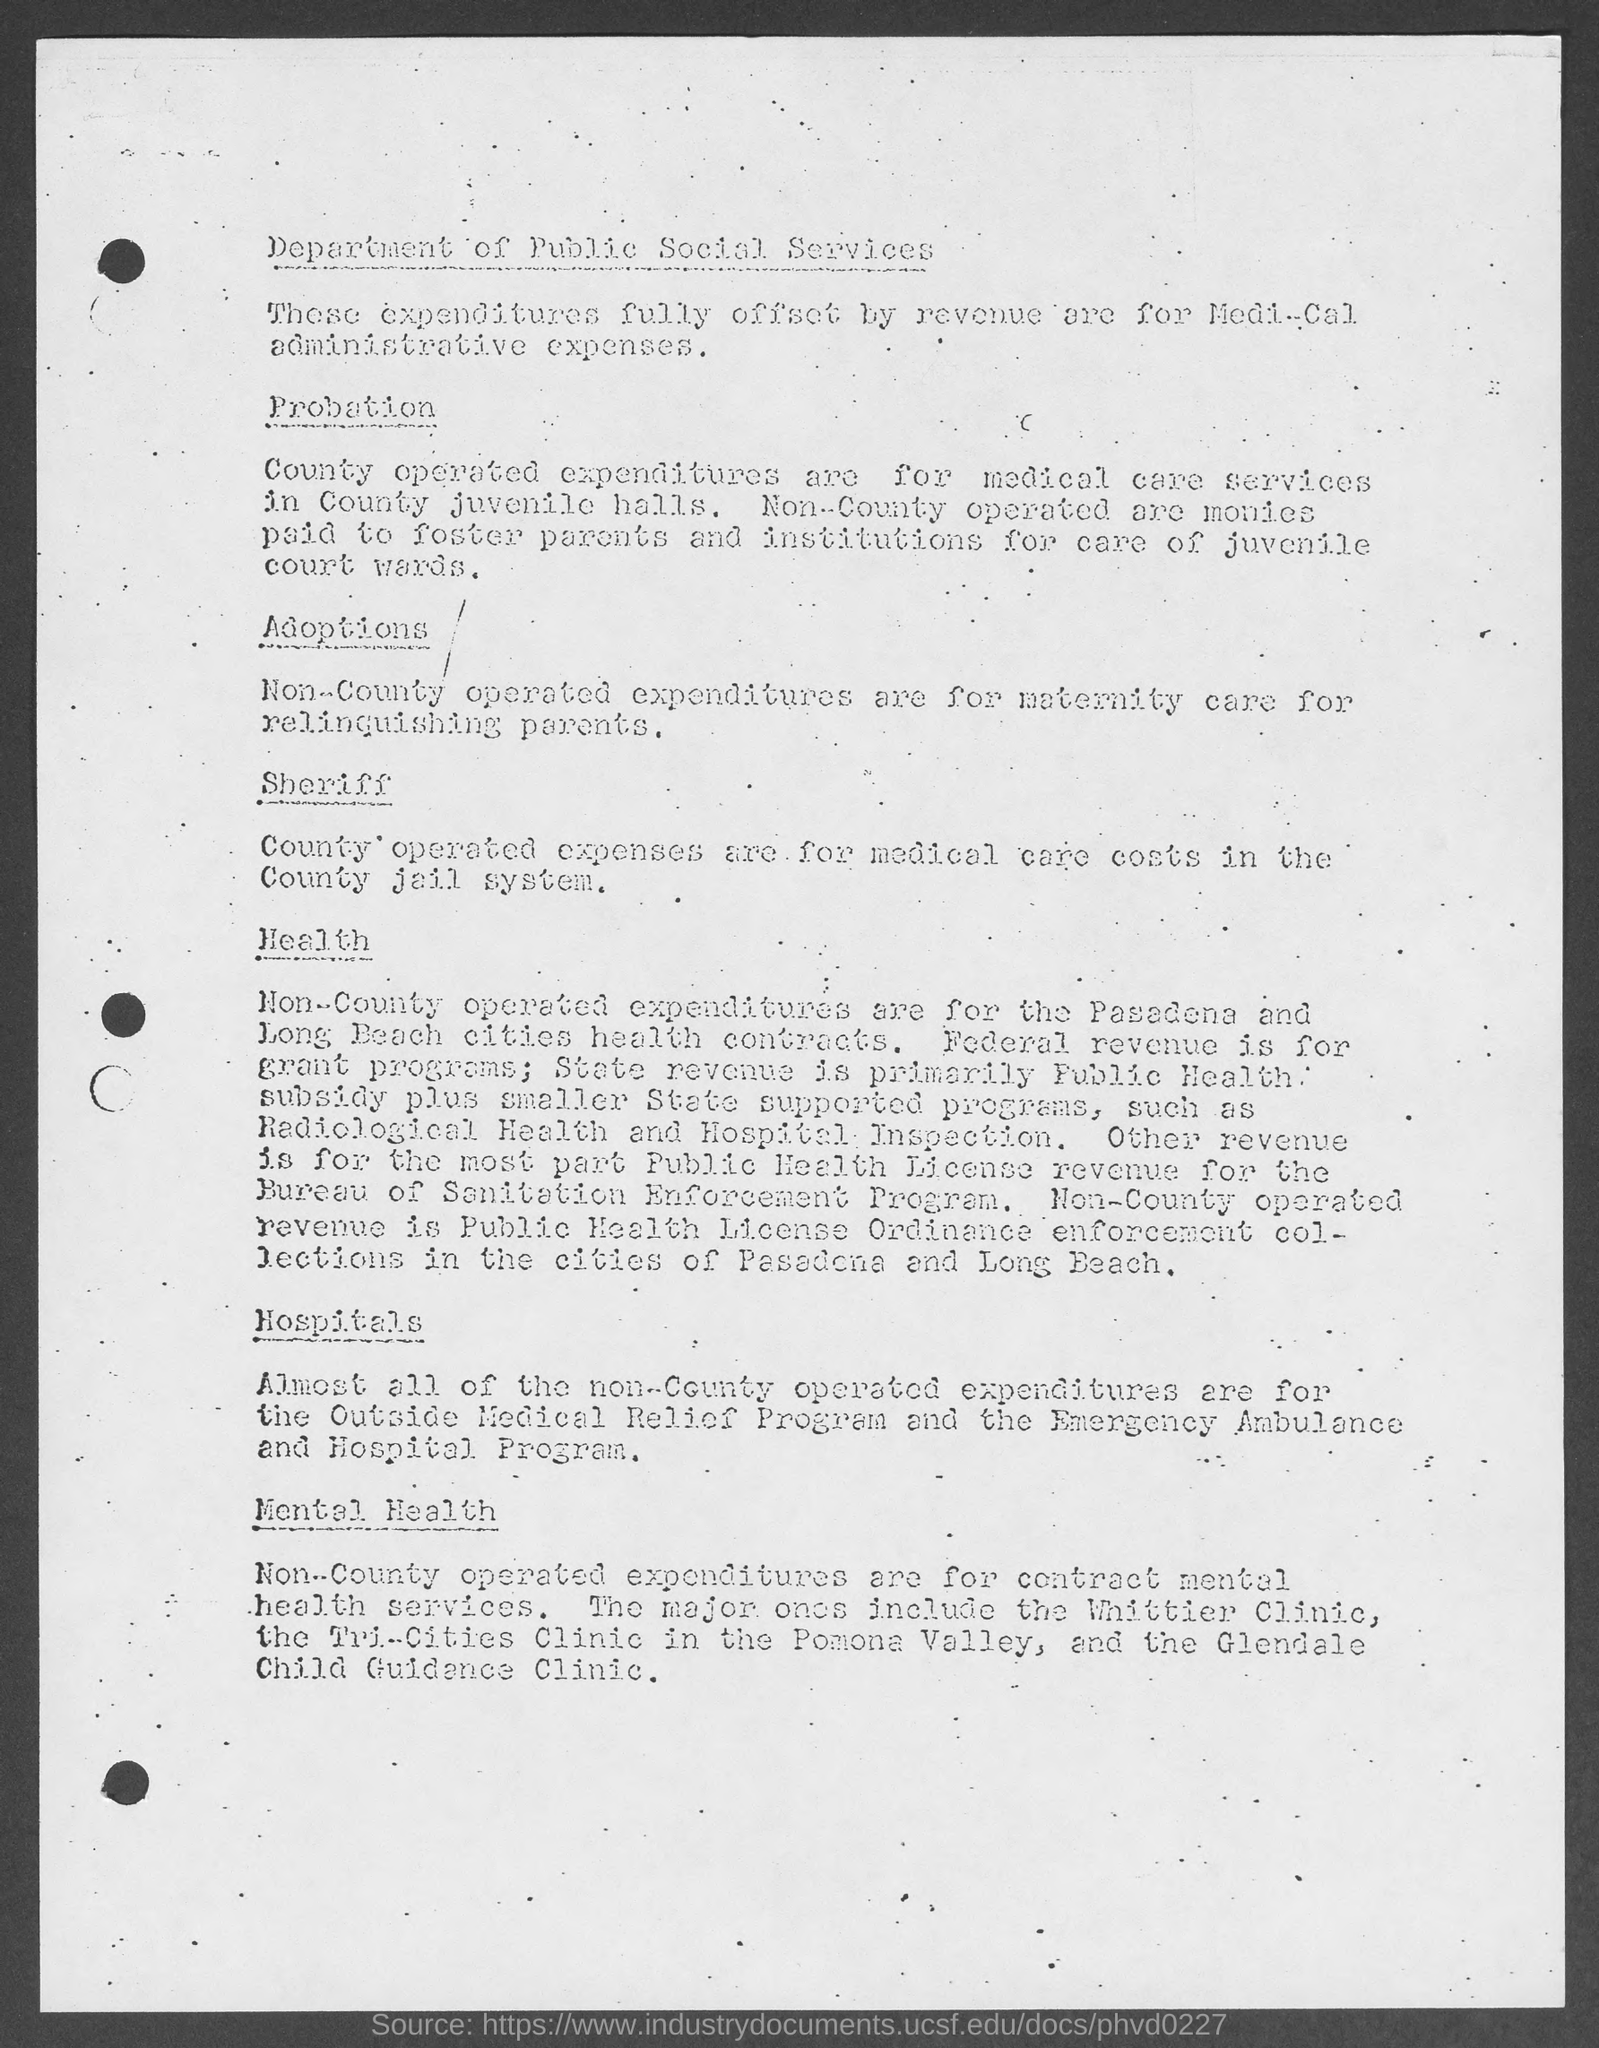What are the County operated expenditures for?
Your answer should be compact. Medical care Services in County juvenile halls. 